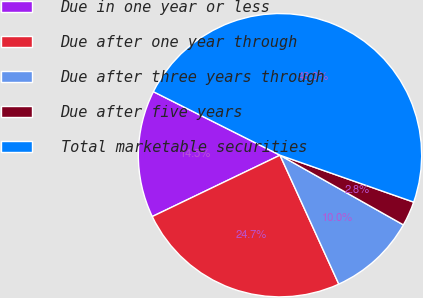<chart> <loc_0><loc_0><loc_500><loc_500><pie_chart><fcel>Due in one year or less<fcel>Due after one year through<fcel>Due after three years through<fcel>Due after five years<fcel>Total marketable securities<nl><fcel>14.53%<fcel>24.69%<fcel>10.01%<fcel>2.81%<fcel>47.97%<nl></chart> 